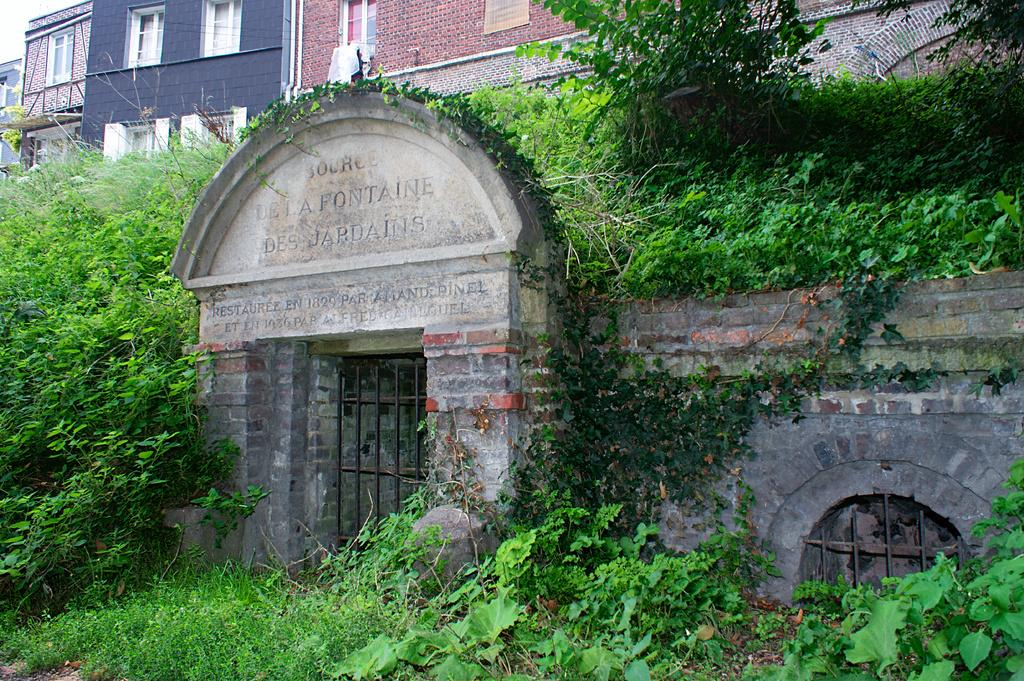What type of structures can be seen in the background of the image? There are buildings in the background of the image. What feature is present in the image that allows access to a different area? There is a door in the image. What type of vegetation is visible at the bottom of the image? There are plants at the bottom of the image. What type of barrier is present in the image? There is a wall in the image. Are there any toys visible in the image? No, there are no toys present in the image. Can you see any signs of burning or pain in the image? No, there are no signs of burning or pain in the image. 